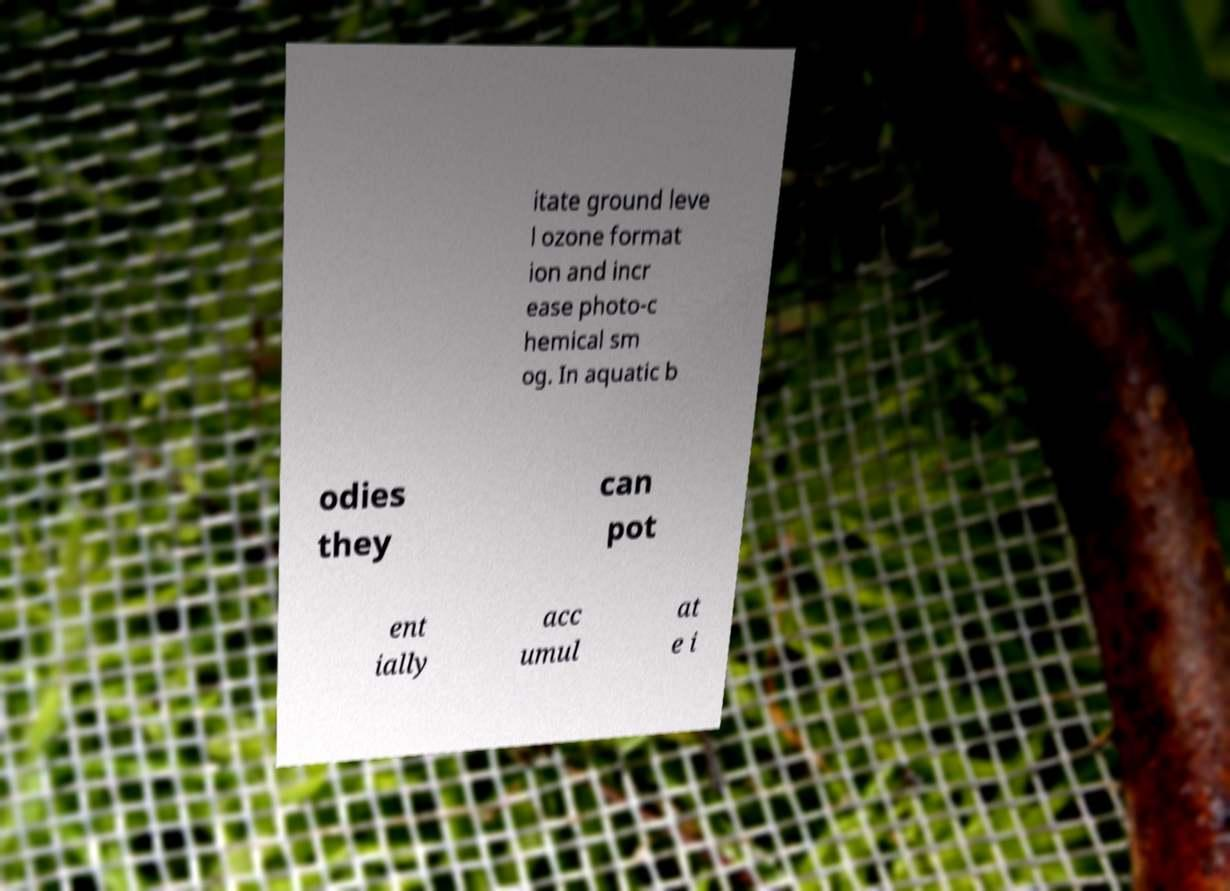There's text embedded in this image that I need extracted. Can you transcribe it verbatim? itate ground leve l ozone format ion and incr ease photo-c hemical sm og. In aquatic b odies they can pot ent ially acc umul at e i 